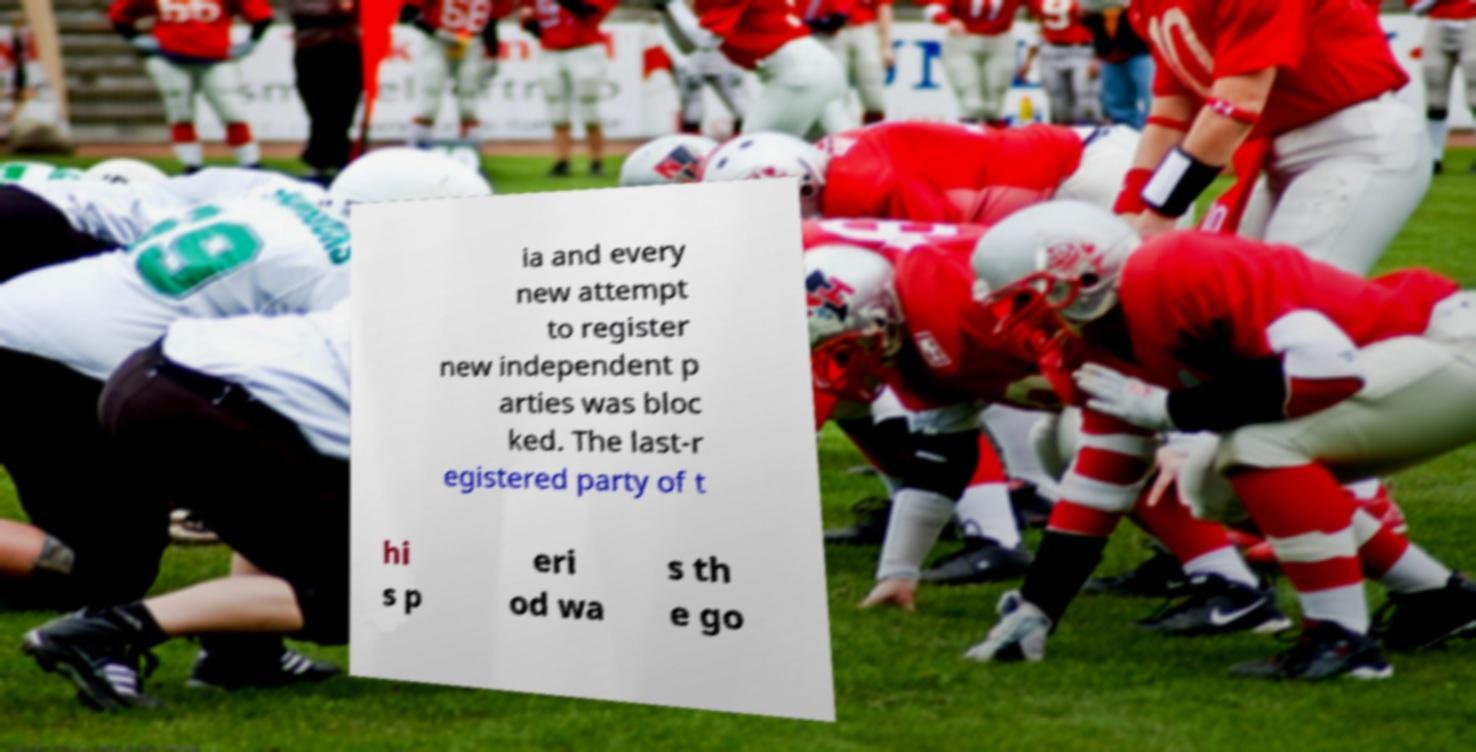There's text embedded in this image that I need extracted. Can you transcribe it verbatim? ia and every new attempt to register new independent p arties was bloc ked. The last-r egistered party of t hi s p eri od wa s th e go 